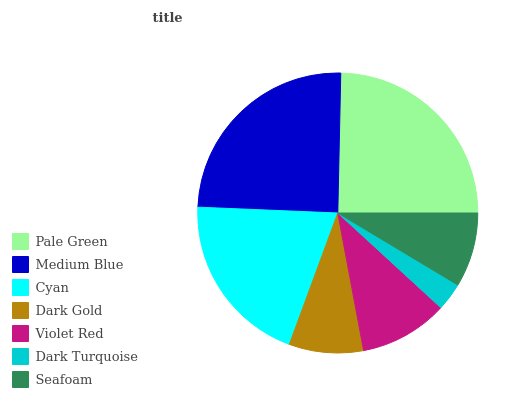Is Dark Turquoise the minimum?
Answer yes or no. Yes. Is Medium Blue the maximum?
Answer yes or no. Yes. Is Cyan the minimum?
Answer yes or no. No. Is Cyan the maximum?
Answer yes or no. No. Is Medium Blue greater than Cyan?
Answer yes or no. Yes. Is Cyan less than Medium Blue?
Answer yes or no. Yes. Is Cyan greater than Medium Blue?
Answer yes or no. No. Is Medium Blue less than Cyan?
Answer yes or no. No. Is Violet Red the high median?
Answer yes or no. Yes. Is Violet Red the low median?
Answer yes or no. Yes. Is Medium Blue the high median?
Answer yes or no. No. Is Seafoam the low median?
Answer yes or no. No. 